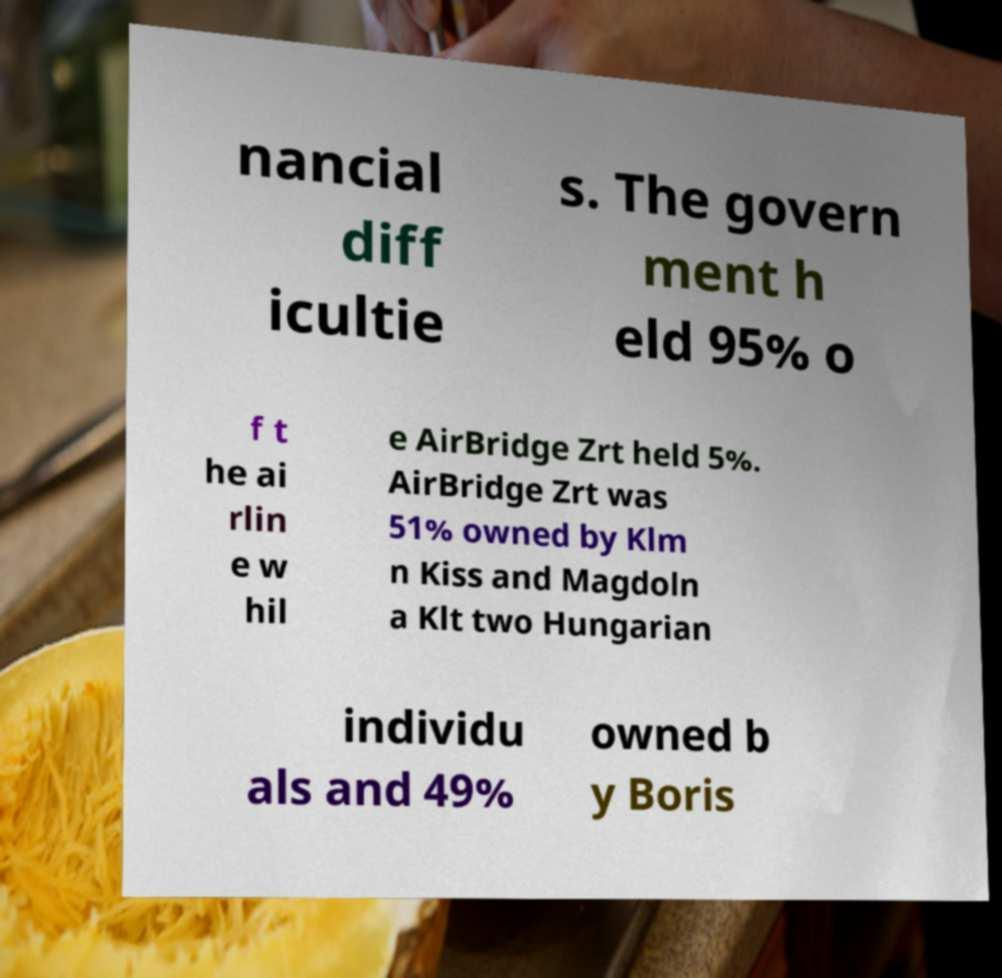Can you accurately transcribe the text from the provided image for me? nancial diff icultie s. The govern ment h eld 95% o f t he ai rlin e w hil e AirBridge Zrt held 5%. AirBridge Zrt was 51% owned by Klm n Kiss and Magdoln a Klt two Hungarian individu als and 49% owned b y Boris 